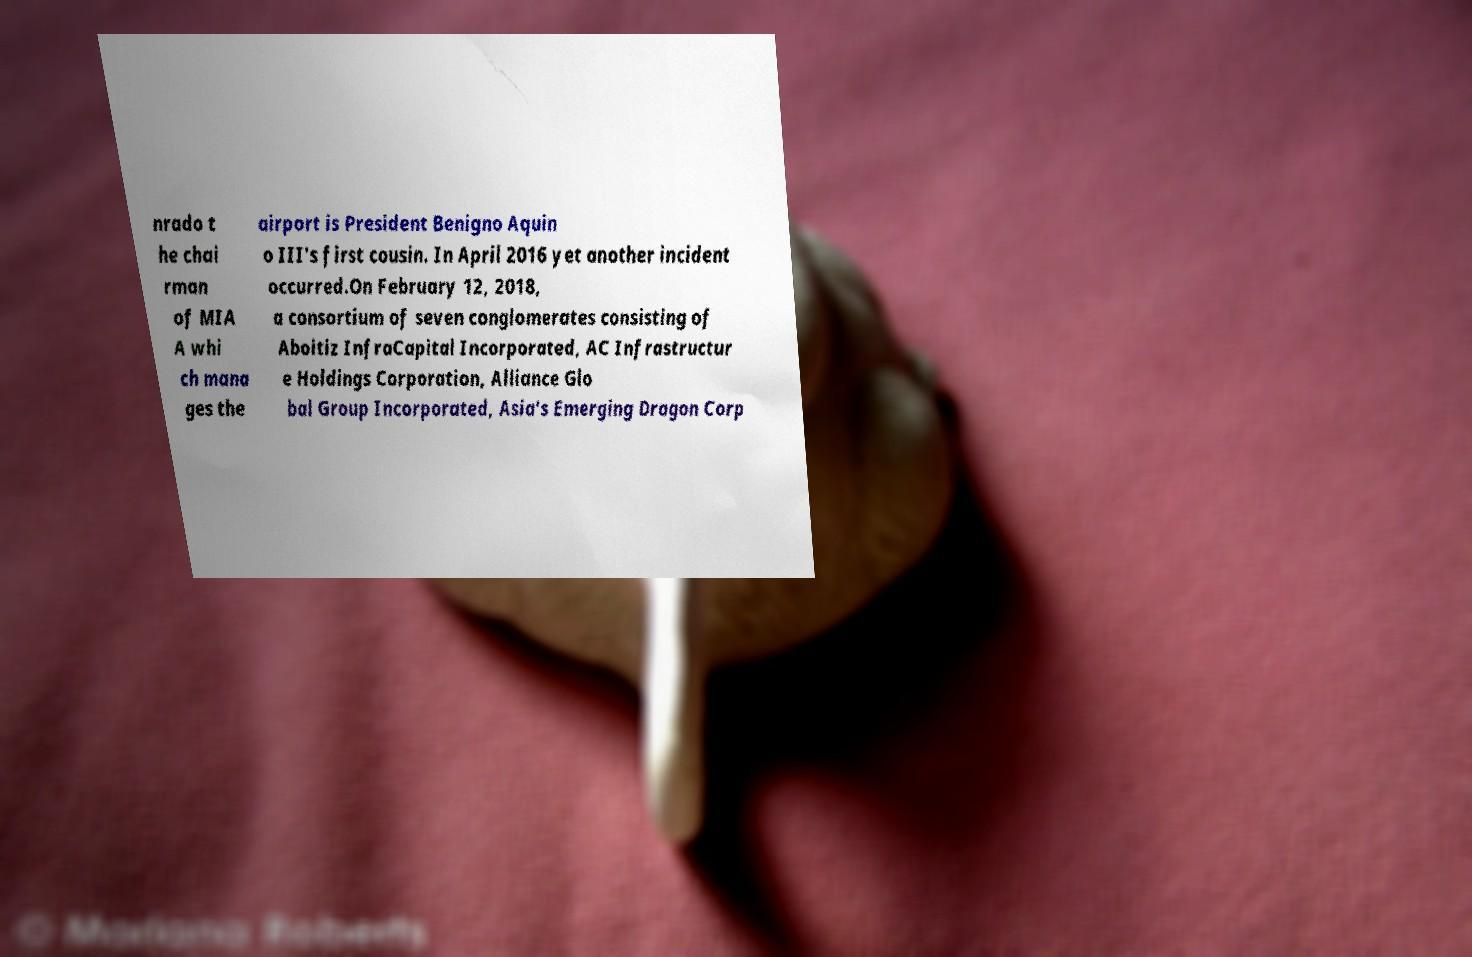Can you read and provide the text displayed in the image?This photo seems to have some interesting text. Can you extract and type it out for me? nrado t he chai rman of MIA A whi ch mana ges the airport is President Benigno Aquin o III's first cousin. In April 2016 yet another incident occurred.On February 12, 2018, a consortium of seven conglomerates consisting of Aboitiz InfraCapital Incorporated, AC Infrastructur e Holdings Corporation, Alliance Glo bal Group Incorporated, Asia's Emerging Dragon Corp 